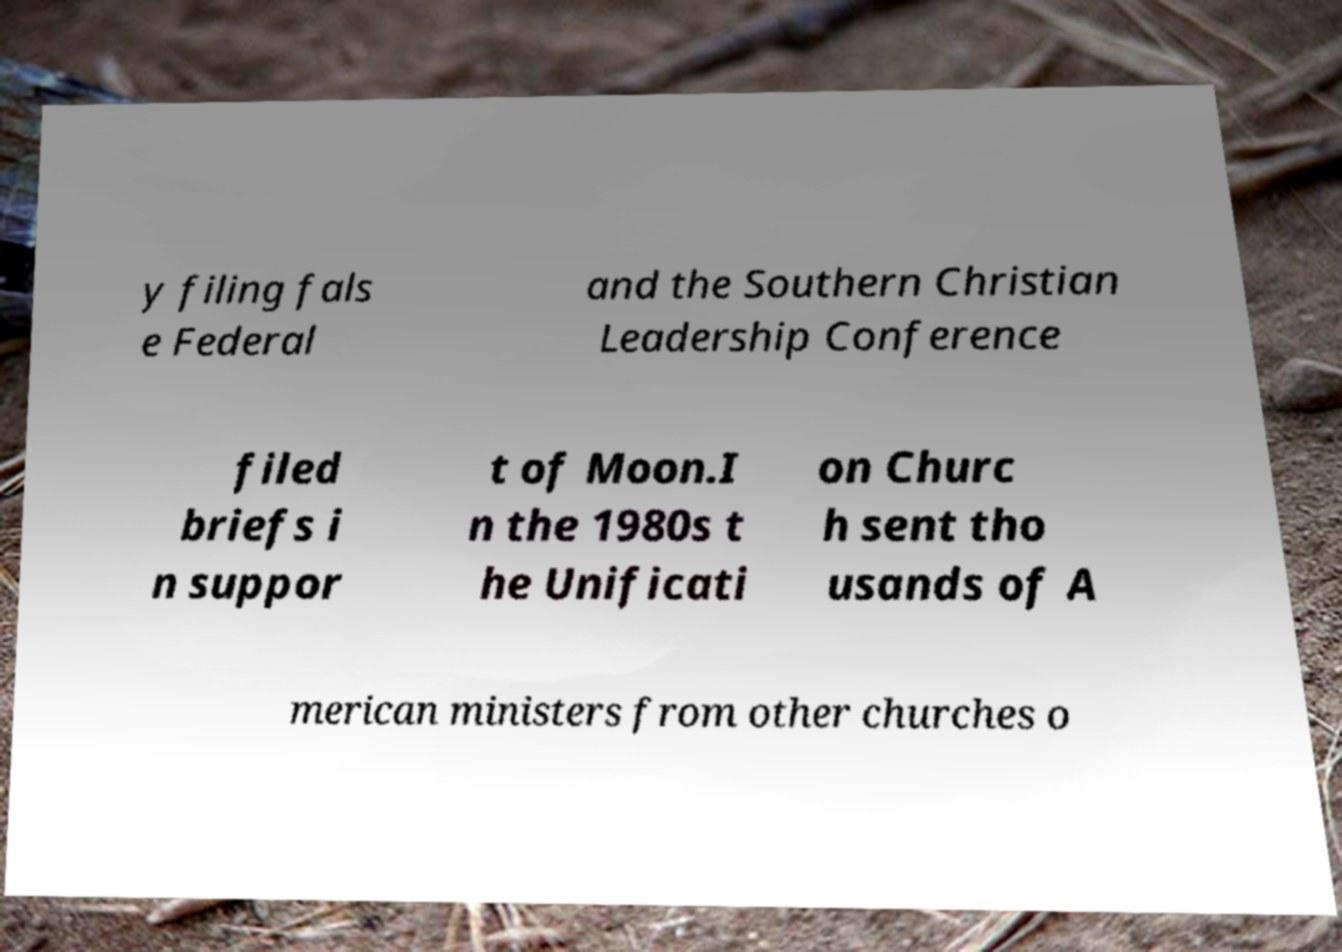I need the written content from this picture converted into text. Can you do that? y filing fals e Federal and the Southern Christian Leadership Conference filed briefs i n suppor t of Moon.I n the 1980s t he Unificati on Churc h sent tho usands of A merican ministers from other churches o 